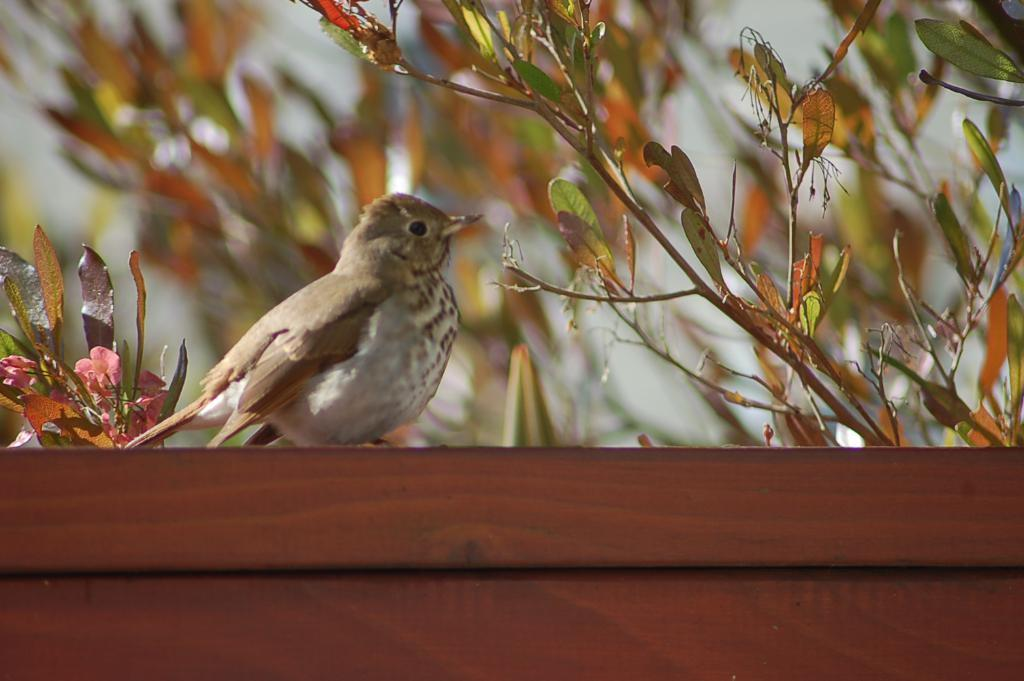What is the main subject in the foreground of the image? There is a bird in the foreground of the image. What can be seen in the background of the image? There are plants in the background of the image. What type of surface is visible at the bottom of the image? There is a wooden surface at the bottom of the image. What type of history is depicted in the bird's underwear in the image? There is no bird's underwear present in the image, and therefore no history can be depicted. 